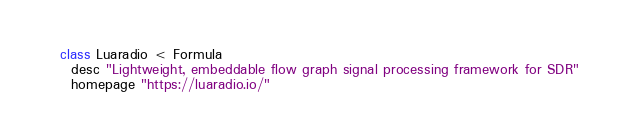Convert code to text. <code><loc_0><loc_0><loc_500><loc_500><_Ruby_>class Luaradio < Formula
  desc "Lightweight, embeddable flow graph signal processing framework for SDR"
  homepage "https://luaradio.io/"</code> 